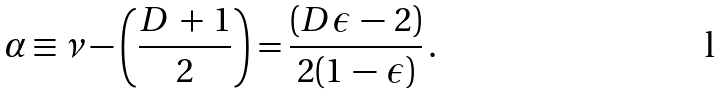<formula> <loc_0><loc_0><loc_500><loc_500>\alpha \equiv \nu - \left ( \frac { D \, + \, 1 } 2 \right ) = \frac { ( D \epsilon \, - \, 2 ) } { 2 ( 1 \, - \, \epsilon ) } \, .</formula> 